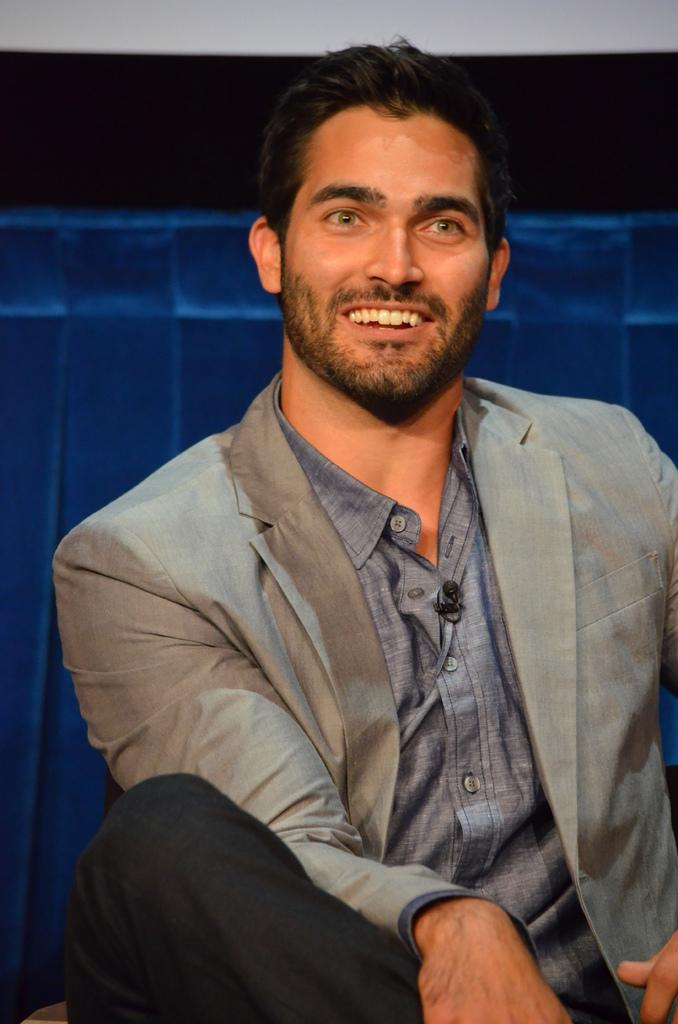Who is present in the image? There is a man in the image. What is the man doing in the image? The man is smiling in the image. What can be seen on the man's shirt? There is a mic on the man's shirt. What color is the object behind the man? There is a blue color object behind the man. What type of fight is the man participating in the image? There is no fight present in the image; the man is simply smiling. How old is the man's daughter in the image? There is no daughter present in the image, as it only features a man. 